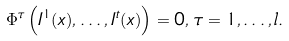Convert formula to latex. <formula><loc_0><loc_0><loc_500><loc_500>\Phi ^ { \tau } \left ( I ^ { 1 } ( x ) , \dots , I ^ { t } ( x ) \right ) = 0 , \, \tau = 1 , \dots , l .</formula> 